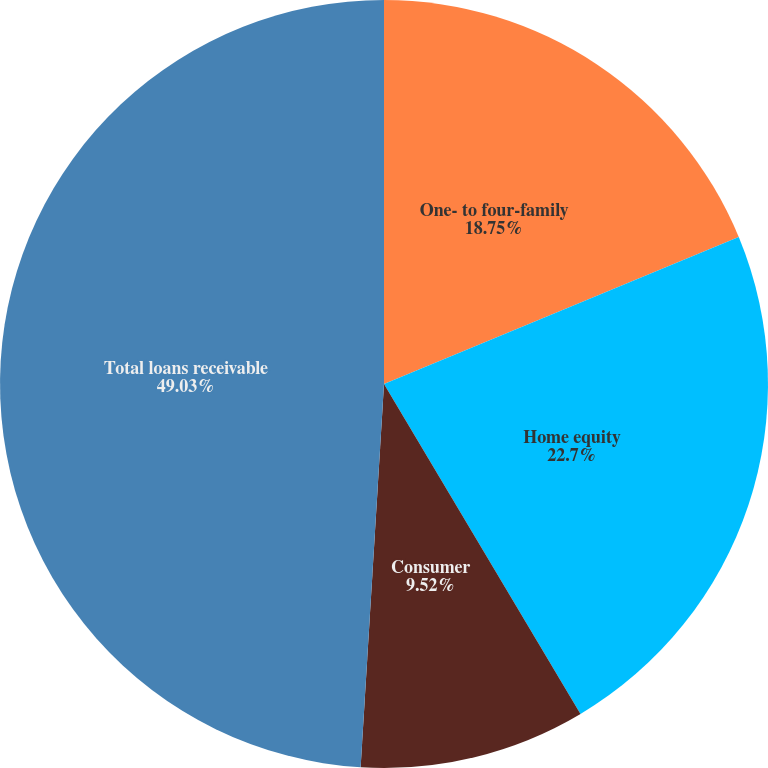<chart> <loc_0><loc_0><loc_500><loc_500><pie_chart><fcel>One- to four-family<fcel>Home equity<fcel>Consumer<fcel>Total loans receivable<nl><fcel>18.75%<fcel>22.7%<fcel>9.52%<fcel>49.03%<nl></chart> 